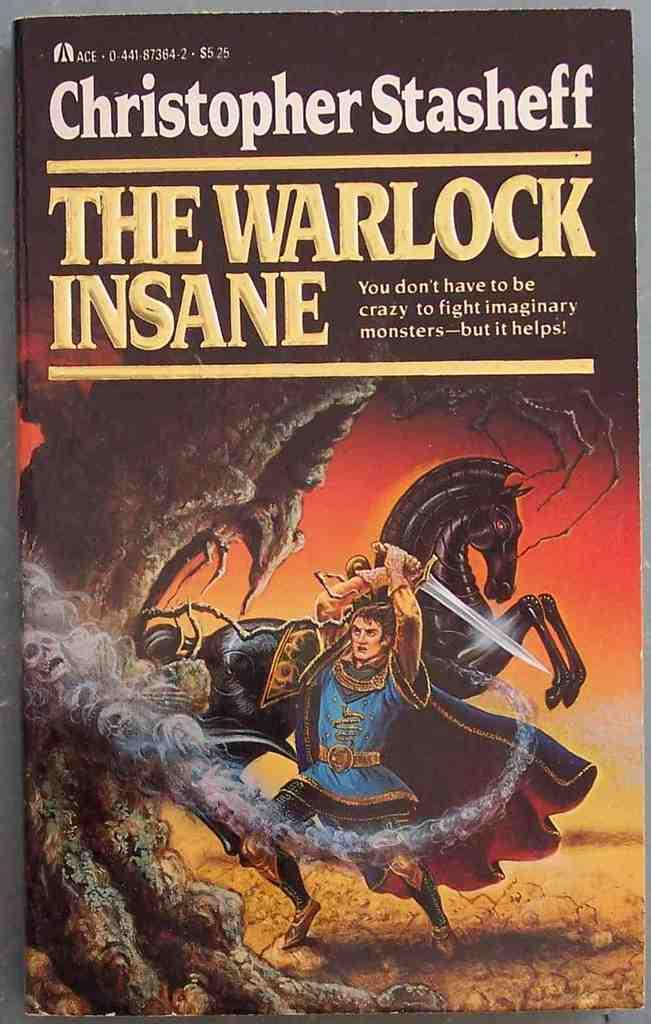<image>
Render a clear and concise summary of the photo. A Christopher Stasheff book called The Warlock Insane. 